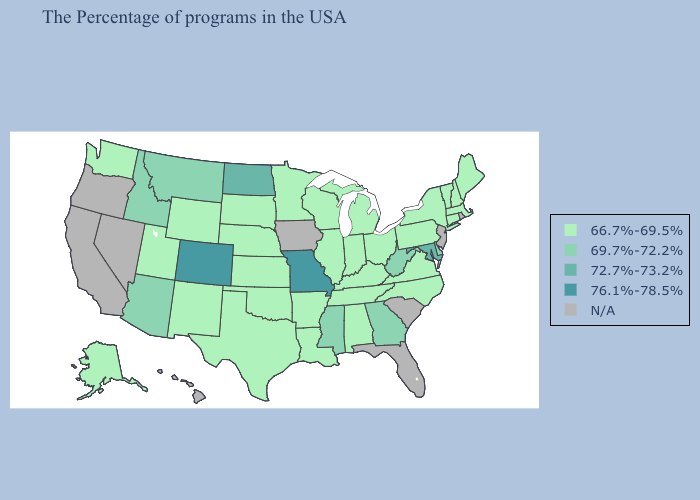What is the value of Pennsylvania?
Keep it brief. 66.7%-69.5%. What is the lowest value in states that border New Jersey?
Short answer required. 66.7%-69.5%. Name the states that have a value in the range 72.7%-73.2%?
Concise answer only. Maryland, North Dakota. Which states have the lowest value in the USA?
Write a very short answer. Maine, Massachusetts, New Hampshire, Vermont, Connecticut, New York, Pennsylvania, Virginia, North Carolina, Ohio, Michigan, Kentucky, Indiana, Alabama, Tennessee, Wisconsin, Illinois, Louisiana, Arkansas, Minnesota, Kansas, Nebraska, Oklahoma, Texas, South Dakota, Wyoming, New Mexico, Utah, Washington, Alaska. Name the states that have a value in the range 66.7%-69.5%?
Quick response, please. Maine, Massachusetts, New Hampshire, Vermont, Connecticut, New York, Pennsylvania, Virginia, North Carolina, Ohio, Michigan, Kentucky, Indiana, Alabama, Tennessee, Wisconsin, Illinois, Louisiana, Arkansas, Minnesota, Kansas, Nebraska, Oklahoma, Texas, South Dakota, Wyoming, New Mexico, Utah, Washington, Alaska. Does New York have the highest value in the USA?
Give a very brief answer. No. What is the highest value in the USA?
Be succinct. 76.1%-78.5%. Name the states that have a value in the range 69.7%-72.2%?
Short answer required. Delaware, West Virginia, Georgia, Mississippi, Montana, Arizona, Idaho. Does Georgia have the lowest value in the South?
Write a very short answer. No. Among the states that border Wyoming , which have the lowest value?
Answer briefly. Nebraska, South Dakota, Utah. Does the map have missing data?
Keep it brief. Yes. What is the value of Iowa?
Answer briefly. N/A. What is the value of Pennsylvania?
Quick response, please. 66.7%-69.5%. 